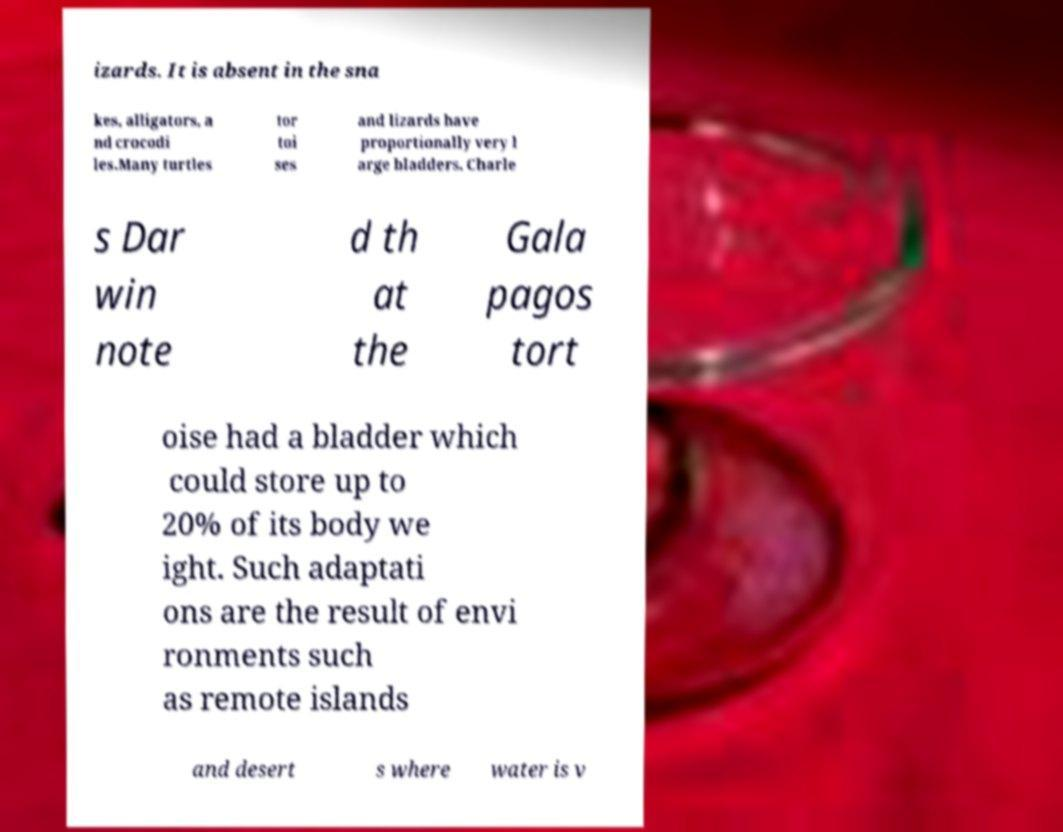I need the written content from this picture converted into text. Can you do that? izards. It is absent in the sna kes, alligators, a nd crocodi les.Many turtles tor toi ses and lizards have proportionally very l arge bladders. Charle s Dar win note d th at the Gala pagos tort oise had a bladder which could store up to 20% of its body we ight. Such adaptati ons are the result of envi ronments such as remote islands and desert s where water is v 